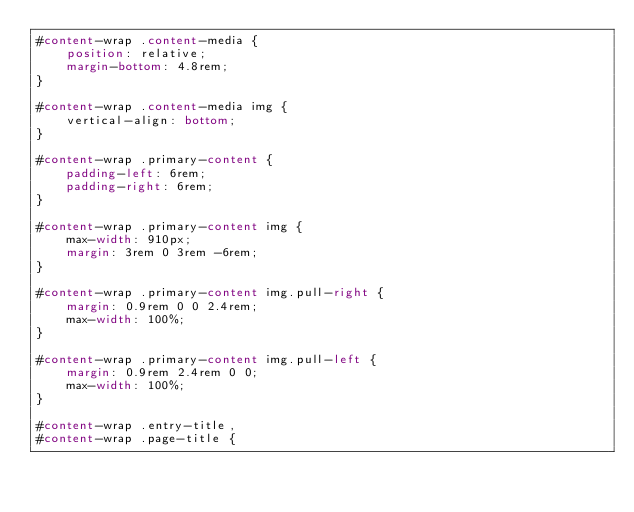<code> <loc_0><loc_0><loc_500><loc_500><_CSS_>#content-wrap .content-media {
	position: relative;
	margin-bottom: 4.8rem;
}

#content-wrap .content-media img {
	vertical-align: bottom;
}

#content-wrap .primary-content {
	padding-left: 6rem;
	padding-right: 6rem;
}

#content-wrap .primary-content img {
	max-width: 910px;
	margin: 3rem 0 3rem -6rem;
}

#content-wrap .primary-content img.pull-right {
	margin: 0.9rem 0 0 2.4rem;
	max-width: 100%;
}

#content-wrap .primary-content img.pull-left {
	margin: 0.9rem 2.4rem 0 0;
	max-width: 100%;
}

#content-wrap .entry-title,
#content-wrap .page-title {</code> 